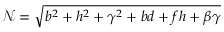Convert formula to latex. <formula><loc_0><loc_0><loc_500><loc_500>\mathcal { N } = \sqrt { b ^ { 2 } + h ^ { 2 } + \gamma ^ { 2 } + b d + f h + \beta \gamma }</formula> 